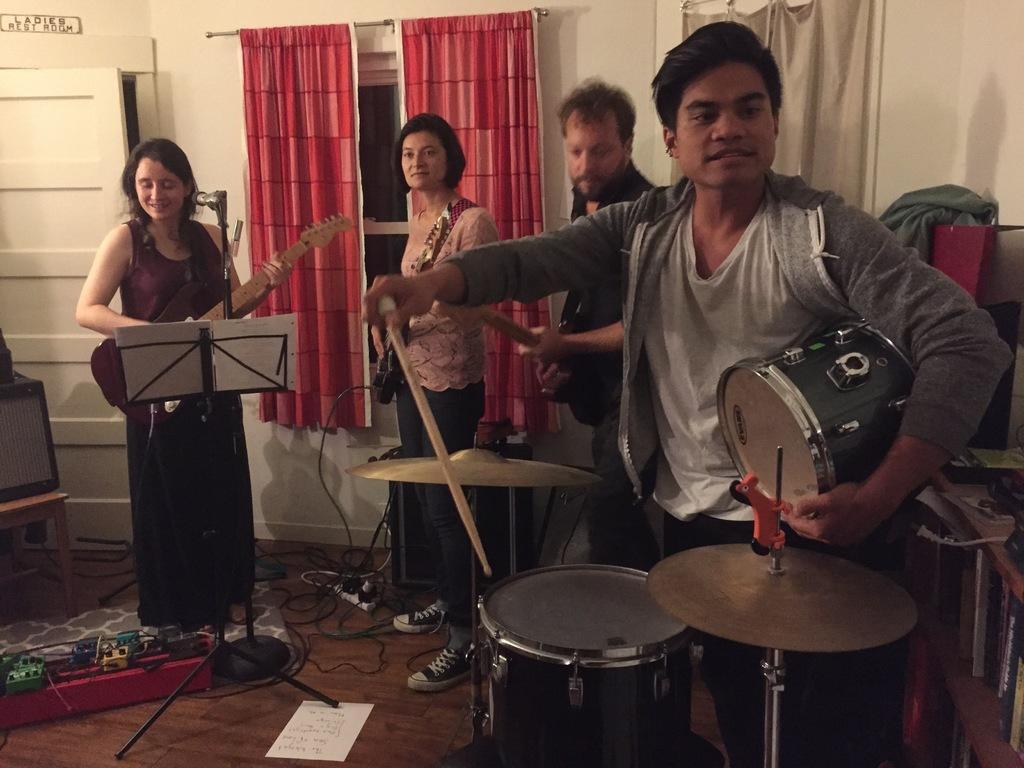How would you summarize this image in a sentence or two? In this image we can see a group of people standing on the floor holding the musical instruments. We can also see a book on a speaker stand, a toy, some wires, a paper, drums and a television on a table on the floor. On the right side we can see some books and objects placed in the shelves. On the backside we can see a window, signboard, door and the curtains. 